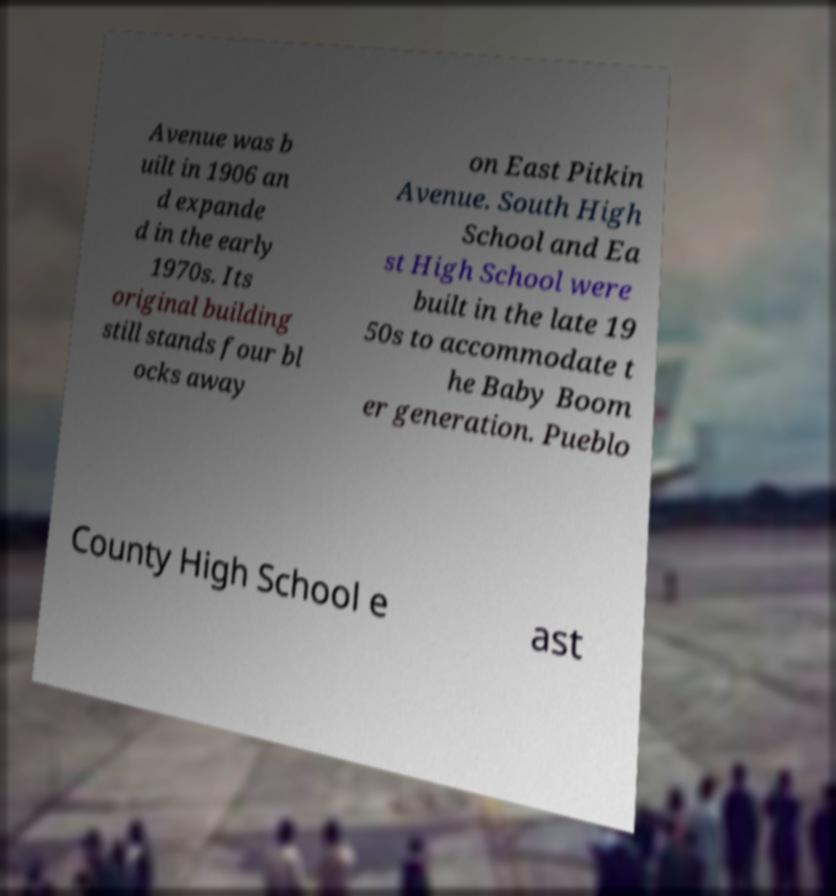Please read and relay the text visible in this image. What does it say? Avenue was b uilt in 1906 an d expande d in the early 1970s. Its original building still stands four bl ocks away on East Pitkin Avenue. South High School and Ea st High School were built in the late 19 50s to accommodate t he Baby Boom er generation. Pueblo County High School e ast 